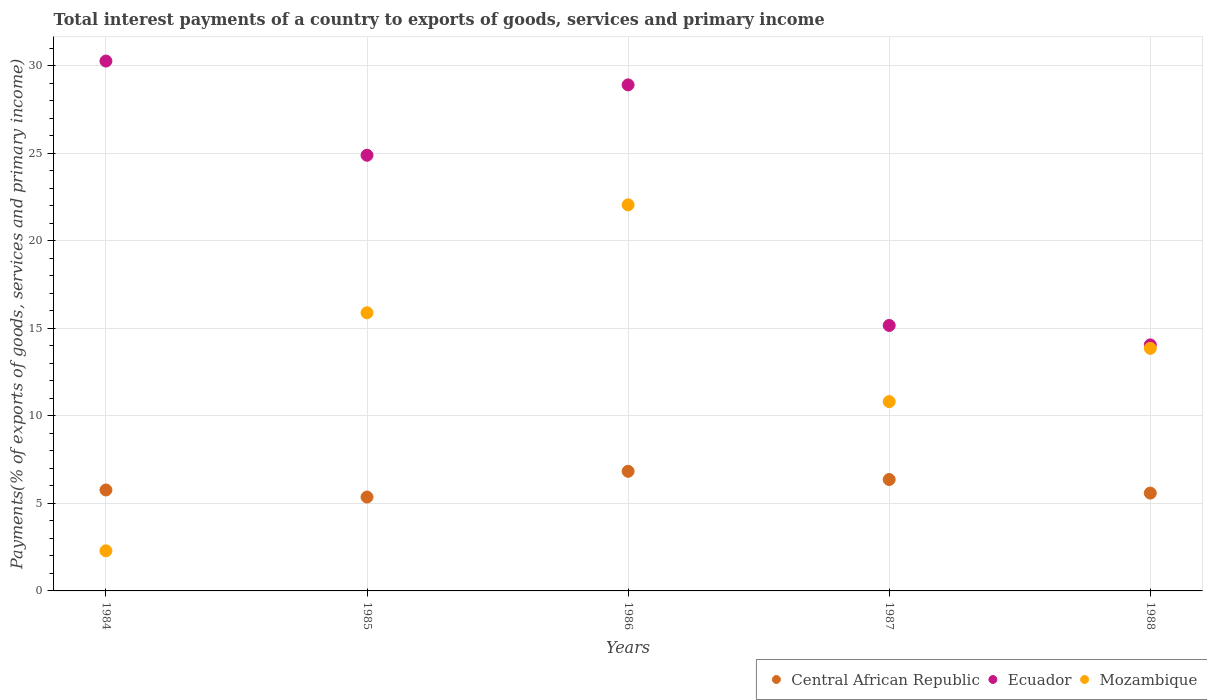How many different coloured dotlines are there?
Provide a short and direct response. 3. Is the number of dotlines equal to the number of legend labels?
Give a very brief answer. Yes. What is the total interest payments in Mozambique in 1986?
Keep it short and to the point. 22.06. Across all years, what is the maximum total interest payments in Ecuador?
Make the answer very short. 30.27. Across all years, what is the minimum total interest payments in Ecuador?
Your response must be concise. 14.06. In which year was the total interest payments in Central African Republic maximum?
Your response must be concise. 1986. What is the total total interest payments in Ecuador in the graph?
Your answer should be compact. 113.29. What is the difference between the total interest payments in Central African Republic in 1984 and that in 1986?
Your answer should be compact. -1.07. What is the difference between the total interest payments in Mozambique in 1986 and the total interest payments in Ecuador in 1987?
Provide a short and direct response. 6.89. What is the average total interest payments in Mozambique per year?
Give a very brief answer. 12.98. In the year 1988, what is the difference between the total interest payments in Mozambique and total interest payments in Ecuador?
Make the answer very short. -0.2. In how many years, is the total interest payments in Ecuador greater than 2 %?
Provide a succinct answer. 5. What is the ratio of the total interest payments in Mozambique in 1984 to that in 1986?
Keep it short and to the point. 0.1. Is the total interest payments in Mozambique in 1986 less than that in 1987?
Provide a succinct answer. No. Is the difference between the total interest payments in Mozambique in 1987 and 1988 greater than the difference between the total interest payments in Ecuador in 1987 and 1988?
Offer a very short reply. No. What is the difference between the highest and the second highest total interest payments in Central African Republic?
Your answer should be compact. 0.47. What is the difference between the highest and the lowest total interest payments in Mozambique?
Provide a succinct answer. 19.77. In how many years, is the total interest payments in Mozambique greater than the average total interest payments in Mozambique taken over all years?
Provide a short and direct response. 3. Is the total interest payments in Ecuador strictly less than the total interest payments in Mozambique over the years?
Provide a succinct answer. No. How many dotlines are there?
Provide a succinct answer. 3. Does the graph contain grids?
Give a very brief answer. Yes. Where does the legend appear in the graph?
Offer a very short reply. Bottom right. What is the title of the graph?
Offer a very short reply. Total interest payments of a country to exports of goods, services and primary income. What is the label or title of the X-axis?
Offer a very short reply. Years. What is the label or title of the Y-axis?
Your answer should be very brief. Payments(% of exports of goods, services and primary income). What is the Payments(% of exports of goods, services and primary income) of Central African Republic in 1984?
Your response must be concise. 5.77. What is the Payments(% of exports of goods, services and primary income) of Ecuador in 1984?
Offer a very short reply. 30.27. What is the Payments(% of exports of goods, services and primary income) in Mozambique in 1984?
Keep it short and to the point. 2.29. What is the Payments(% of exports of goods, services and primary income) of Central African Republic in 1985?
Keep it short and to the point. 5.36. What is the Payments(% of exports of goods, services and primary income) in Ecuador in 1985?
Offer a very short reply. 24.89. What is the Payments(% of exports of goods, services and primary income) in Mozambique in 1985?
Ensure brevity in your answer.  15.89. What is the Payments(% of exports of goods, services and primary income) in Central African Republic in 1986?
Your answer should be compact. 6.83. What is the Payments(% of exports of goods, services and primary income) in Ecuador in 1986?
Offer a terse response. 28.91. What is the Payments(% of exports of goods, services and primary income) of Mozambique in 1986?
Keep it short and to the point. 22.06. What is the Payments(% of exports of goods, services and primary income) of Central African Republic in 1987?
Offer a terse response. 6.36. What is the Payments(% of exports of goods, services and primary income) of Ecuador in 1987?
Keep it short and to the point. 15.17. What is the Payments(% of exports of goods, services and primary income) in Mozambique in 1987?
Make the answer very short. 10.82. What is the Payments(% of exports of goods, services and primary income) of Central African Republic in 1988?
Provide a succinct answer. 5.59. What is the Payments(% of exports of goods, services and primary income) in Ecuador in 1988?
Offer a terse response. 14.06. What is the Payments(% of exports of goods, services and primary income) in Mozambique in 1988?
Make the answer very short. 13.86. Across all years, what is the maximum Payments(% of exports of goods, services and primary income) of Central African Republic?
Your answer should be compact. 6.83. Across all years, what is the maximum Payments(% of exports of goods, services and primary income) in Ecuador?
Provide a short and direct response. 30.27. Across all years, what is the maximum Payments(% of exports of goods, services and primary income) of Mozambique?
Your answer should be compact. 22.06. Across all years, what is the minimum Payments(% of exports of goods, services and primary income) in Central African Republic?
Your response must be concise. 5.36. Across all years, what is the minimum Payments(% of exports of goods, services and primary income) in Ecuador?
Offer a very short reply. 14.06. Across all years, what is the minimum Payments(% of exports of goods, services and primary income) of Mozambique?
Offer a terse response. 2.29. What is the total Payments(% of exports of goods, services and primary income) of Central African Republic in the graph?
Provide a succinct answer. 29.92. What is the total Payments(% of exports of goods, services and primary income) of Ecuador in the graph?
Offer a very short reply. 113.29. What is the total Payments(% of exports of goods, services and primary income) in Mozambique in the graph?
Give a very brief answer. 64.91. What is the difference between the Payments(% of exports of goods, services and primary income) in Central African Republic in 1984 and that in 1985?
Ensure brevity in your answer.  0.4. What is the difference between the Payments(% of exports of goods, services and primary income) in Ecuador in 1984 and that in 1985?
Offer a terse response. 5.38. What is the difference between the Payments(% of exports of goods, services and primary income) in Mozambique in 1984 and that in 1985?
Provide a succinct answer. -13.6. What is the difference between the Payments(% of exports of goods, services and primary income) in Central African Republic in 1984 and that in 1986?
Ensure brevity in your answer.  -1.07. What is the difference between the Payments(% of exports of goods, services and primary income) of Ecuador in 1984 and that in 1986?
Your answer should be very brief. 1.36. What is the difference between the Payments(% of exports of goods, services and primary income) of Mozambique in 1984 and that in 1986?
Provide a short and direct response. -19.77. What is the difference between the Payments(% of exports of goods, services and primary income) of Central African Republic in 1984 and that in 1987?
Offer a terse response. -0.6. What is the difference between the Payments(% of exports of goods, services and primary income) in Ecuador in 1984 and that in 1987?
Offer a terse response. 15.1. What is the difference between the Payments(% of exports of goods, services and primary income) of Mozambique in 1984 and that in 1987?
Make the answer very short. -8.52. What is the difference between the Payments(% of exports of goods, services and primary income) of Central African Republic in 1984 and that in 1988?
Offer a terse response. 0.18. What is the difference between the Payments(% of exports of goods, services and primary income) in Ecuador in 1984 and that in 1988?
Provide a succinct answer. 16.21. What is the difference between the Payments(% of exports of goods, services and primary income) in Mozambique in 1984 and that in 1988?
Keep it short and to the point. -11.57. What is the difference between the Payments(% of exports of goods, services and primary income) of Central African Republic in 1985 and that in 1986?
Ensure brevity in your answer.  -1.47. What is the difference between the Payments(% of exports of goods, services and primary income) in Ecuador in 1985 and that in 1986?
Your response must be concise. -4.02. What is the difference between the Payments(% of exports of goods, services and primary income) in Mozambique in 1985 and that in 1986?
Make the answer very short. -6.17. What is the difference between the Payments(% of exports of goods, services and primary income) in Central African Republic in 1985 and that in 1987?
Keep it short and to the point. -1. What is the difference between the Payments(% of exports of goods, services and primary income) in Ecuador in 1985 and that in 1987?
Keep it short and to the point. 9.72. What is the difference between the Payments(% of exports of goods, services and primary income) in Mozambique in 1985 and that in 1987?
Offer a terse response. 5.08. What is the difference between the Payments(% of exports of goods, services and primary income) of Central African Republic in 1985 and that in 1988?
Keep it short and to the point. -0.23. What is the difference between the Payments(% of exports of goods, services and primary income) in Ecuador in 1985 and that in 1988?
Ensure brevity in your answer.  10.83. What is the difference between the Payments(% of exports of goods, services and primary income) in Mozambique in 1985 and that in 1988?
Keep it short and to the point. 2.03. What is the difference between the Payments(% of exports of goods, services and primary income) of Central African Republic in 1986 and that in 1987?
Make the answer very short. 0.47. What is the difference between the Payments(% of exports of goods, services and primary income) of Ecuador in 1986 and that in 1987?
Ensure brevity in your answer.  13.74. What is the difference between the Payments(% of exports of goods, services and primary income) of Mozambique in 1986 and that in 1987?
Your answer should be very brief. 11.24. What is the difference between the Payments(% of exports of goods, services and primary income) in Central African Republic in 1986 and that in 1988?
Provide a short and direct response. 1.24. What is the difference between the Payments(% of exports of goods, services and primary income) of Ecuador in 1986 and that in 1988?
Give a very brief answer. 14.85. What is the difference between the Payments(% of exports of goods, services and primary income) in Mozambique in 1986 and that in 1988?
Your answer should be compact. 8.2. What is the difference between the Payments(% of exports of goods, services and primary income) in Central African Republic in 1987 and that in 1988?
Make the answer very short. 0.77. What is the difference between the Payments(% of exports of goods, services and primary income) of Ecuador in 1987 and that in 1988?
Your response must be concise. 1.11. What is the difference between the Payments(% of exports of goods, services and primary income) of Mozambique in 1987 and that in 1988?
Make the answer very short. -3.04. What is the difference between the Payments(% of exports of goods, services and primary income) in Central African Republic in 1984 and the Payments(% of exports of goods, services and primary income) in Ecuador in 1985?
Ensure brevity in your answer.  -19.12. What is the difference between the Payments(% of exports of goods, services and primary income) of Central African Republic in 1984 and the Payments(% of exports of goods, services and primary income) of Mozambique in 1985?
Your response must be concise. -10.12. What is the difference between the Payments(% of exports of goods, services and primary income) in Ecuador in 1984 and the Payments(% of exports of goods, services and primary income) in Mozambique in 1985?
Keep it short and to the point. 14.38. What is the difference between the Payments(% of exports of goods, services and primary income) of Central African Republic in 1984 and the Payments(% of exports of goods, services and primary income) of Ecuador in 1986?
Provide a succinct answer. -23.14. What is the difference between the Payments(% of exports of goods, services and primary income) of Central African Republic in 1984 and the Payments(% of exports of goods, services and primary income) of Mozambique in 1986?
Give a very brief answer. -16.29. What is the difference between the Payments(% of exports of goods, services and primary income) of Ecuador in 1984 and the Payments(% of exports of goods, services and primary income) of Mozambique in 1986?
Keep it short and to the point. 8.21. What is the difference between the Payments(% of exports of goods, services and primary income) in Central African Republic in 1984 and the Payments(% of exports of goods, services and primary income) in Ecuador in 1987?
Give a very brief answer. -9.4. What is the difference between the Payments(% of exports of goods, services and primary income) of Central African Republic in 1984 and the Payments(% of exports of goods, services and primary income) of Mozambique in 1987?
Provide a short and direct response. -5.05. What is the difference between the Payments(% of exports of goods, services and primary income) of Ecuador in 1984 and the Payments(% of exports of goods, services and primary income) of Mozambique in 1987?
Provide a short and direct response. 19.46. What is the difference between the Payments(% of exports of goods, services and primary income) in Central African Republic in 1984 and the Payments(% of exports of goods, services and primary income) in Ecuador in 1988?
Your answer should be compact. -8.29. What is the difference between the Payments(% of exports of goods, services and primary income) in Central African Republic in 1984 and the Payments(% of exports of goods, services and primary income) in Mozambique in 1988?
Your answer should be very brief. -8.09. What is the difference between the Payments(% of exports of goods, services and primary income) in Ecuador in 1984 and the Payments(% of exports of goods, services and primary income) in Mozambique in 1988?
Give a very brief answer. 16.41. What is the difference between the Payments(% of exports of goods, services and primary income) of Central African Republic in 1985 and the Payments(% of exports of goods, services and primary income) of Ecuador in 1986?
Provide a short and direct response. -23.55. What is the difference between the Payments(% of exports of goods, services and primary income) of Central African Republic in 1985 and the Payments(% of exports of goods, services and primary income) of Mozambique in 1986?
Provide a short and direct response. -16.69. What is the difference between the Payments(% of exports of goods, services and primary income) of Ecuador in 1985 and the Payments(% of exports of goods, services and primary income) of Mozambique in 1986?
Your answer should be compact. 2.83. What is the difference between the Payments(% of exports of goods, services and primary income) in Central African Republic in 1985 and the Payments(% of exports of goods, services and primary income) in Ecuador in 1987?
Your answer should be very brief. -9.8. What is the difference between the Payments(% of exports of goods, services and primary income) in Central African Republic in 1985 and the Payments(% of exports of goods, services and primary income) in Mozambique in 1987?
Make the answer very short. -5.45. What is the difference between the Payments(% of exports of goods, services and primary income) of Ecuador in 1985 and the Payments(% of exports of goods, services and primary income) of Mozambique in 1987?
Ensure brevity in your answer.  14.07. What is the difference between the Payments(% of exports of goods, services and primary income) of Central African Republic in 1985 and the Payments(% of exports of goods, services and primary income) of Ecuador in 1988?
Your response must be concise. -8.69. What is the difference between the Payments(% of exports of goods, services and primary income) in Central African Republic in 1985 and the Payments(% of exports of goods, services and primary income) in Mozambique in 1988?
Your response must be concise. -8.5. What is the difference between the Payments(% of exports of goods, services and primary income) in Ecuador in 1985 and the Payments(% of exports of goods, services and primary income) in Mozambique in 1988?
Your answer should be compact. 11.03. What is the difference between the Payments(% of exports of goods, services and primary income) of Central African Republic in 1986 and the Payments(% of exports of goods, services and primary income) of Ecuador in 1987?
Provide a succinct answer. -8.33. What is the difference between the Payments(% of exports of goods, services and primary income) of Central African Republic in 1986 and the Payments(% of exports of goods, services and primary income) of Mozambique in 1987?
Offer a terse response. -3.98. What is the difference between the Payments(% of exports of goods, services and primary income) of Ecuador in 1986 and the Payments(% of exports of goods, services and primary income) of Mozambique in 1987?
Give a very brief answer. 18.09. What is the difference between the Payments(% of exports of goods, services and primary income) of Central African Republic in 1986 and the Payments(% of exports of goods, services and primary income) of Ecuador in 1988?
Your answer should be compact. -7.22. What is the difference between the Payments(% of exports of goods, services and primary income) in Central African Republic in 1986 and the Payments(% of exports of goods, services and primary income) in Mozambique in 1988?
Your answer should be very brief. -7.02. What is the difference between the Payments(% of exports of goods, services and primary income) in Ecuador in 1986 and the Payments(% of exports of goods, services and primary income) in Mozambique in 1988?
Give a very brief answer. 15.05. What is the difference between the Payments(% of exports of goods, services and primary income) in Central African Republic in 1987 and the Payments(% of exports of goods, services and primary income) in Ecuador in 1988?
Give a very brief answer. -7.69. What is the difference between the Payments(% of exports of goods, services and primary income) in Central African Republic in 1987 and the Payments(% of exports of goods, services and primary income) in Mozambique in 1988?
Offer a very short reply. -7.49. What is the difference between the Payments(% of exports of goods, services and primary income) of Ecuador in 1987 and the Payments(% of exports of goods, services and primary income) of Mozambique in 1988?
Your answer should be very brief. 1.31. What is the average Payments(% of exports of goods, services and primary income) in Central African Republic per year?
Keep it short and to the point. 5.98. What is the average Payments(% of exports of goods, services and primary income) in Ecuador per year?
Your answer should be very brief. 22.66. What is the average Payments(% of exports of goods, services and primary income) of Mozambique per year?
Provide a succinct answer. 12.98. In the year 1984, what is the difference between the Payments(% of exports of goods, services and primary income) of Central African Republic and Payments(% of exports of goods, services and primary income) of Ecuador?
Ensure brevity in your answer.  -24.5. In the year 1984, what is the difference between the Payments(% of exports of goods, services and primary income) in Central African Republic and Payments(% of exports of goods, services and primary income) in Mozambique?
Make the answer very short. 3.48. In the year 1984, what is the difference between the Payments(% of exports of goods, services and primary income) in Ecuador and Payments(% of exports of goods, services and primary income) in Mozambique?
Give a very brief answer. 27.98. In the year 1985, what is the difference between the Payments(% of exports of goods, services and primary income) of Central African Republic and Payments(% of exports of goods, services and primary income) of Ecuador?
Offer a very short reply. -19.53. In the year 1985, what is the difference between the Payments(% of exports of goods, services and primary income) of Central African Republic and Payments(% of exports of goods, services and primary income) of Mozambique?
Your answer should be compact. -10.53. In the year 1985, what is the difference between the Payments(% of exports of goods, services and primary income) in Ecuador and Payments(% of exports of goods, services and primary income) in Mozambique?
Your answer should be compact. 9. In the year 1986, what is the difference between the Payments(% of exports of goods, services and primary income) in Central African Republic and Payments(% of exports of goods, services and primary income) in Ecuador?
Your answer should be compact. -22.08. In the year 1986, what is the difference between the Payments(% of exports of goods, services and primary income) in Central African Republic and Payments(% of exports of goods, services and primary income) in Mozambique?
Offer a terse response. -15.22. In the year 1986, what is the difference between the Payments(% of exports of goods, services and primary income) of Ecuador and Payments(% of exports of goods, services and primary income) of Mozambique?
Your response must be concise. 6.85. In the year 1987, what is the difference between the Payments(% of exports of goods, services and primary income) in Central African Republic and Payments(% of exports of goods, services and primary income) in Ecuador?
Offer a terse response. -8.8. In the year 1987, what is the difference between the Payments(% of exports of goods, services and primary income) of Central African Republic and Payments(% of exports of goods, services and primary income) of Mozambique?
Give a very brief answer. -4.45. In the year 1987, what is the difference between the Payments(% of exports of goods, services and primary income) of Ecuador and Payments(% of exports of goods, services and primary income) of Mozambique?
Provide a short and direct response. 4.35. In the year 1988, what is the difference between the Payments(% of exports of goods, services and primary income) of Central African Republic and Payments(% of exports of goods, services and primary income) of Ecuador?
Provide a short and direct response. -8.47. In the year 1988, what is the difference between the Payments(% of exports of goods, services and primary income) in Central African Republic and Payments(% of exports of goods, services and primary income) in Mozambique?
Your response must be concise. -8.27. In the year 1988, what is the difference between the Payments(% of exports of goods, services and primary income) in Ecuador and Payments(% of exports of goods, services and primary income) in Mozambique?
Provide a succinct answer. 0.2. What is the ratio of the Payments(% of exports of goods, services and primary income) in Central African Republic in 1984 to that in 1985?
Give a very brief answer. 1.08. What is the ratio of the Payments(% of exports of goods, services and primary income) of Ecuador in 1984 to that in 1985?
Give a very brief answer. 1.22. What is the ratio of the Payments(% of exports of goods, services and primary income) in Mozambique in 1984 to that in 1985?
Give a very brief answer. 0.14. What is the ratio of the Payments(% of exports of goods, services and primary income) of Central African Republic in 1984 to that in 1986?
Provide a short and direct response. 0.84. What is the ratio of the Payments(% of exports of goods, services and primary income) in Ecuador in 1984 to that in 1986?
Provide a short and direct response. 1.05. What is the ratio of the Payments(% of exports of goods, services and primary income) in Mozambique in 1984 to that in 1986?
Provide a succinct answer. 0.1. What is the ratio of the Payments(% of exports of goods, services and primary income) in Central African Republic in 1984 to that in 1987?
Make the answer very short. 0.91. What is the ratio of the Payments(% of exports of goods, services and primary income) of Ecuador in 1984 to that in 1987?
Your answer should be very brief. 2. What is the ratio of the Payments(% of exports of goods, services and primary income) in Mozambique in 1984 to that in 1987?
Offer a very short reply. 0.21. What is the ratio of the Payments(% of exports of goods, services and primary income) in Central African Republic in 1984 to that in 1988?
Provide a succinct answer. 1.03. What is the ratio of the Payments(% of exports of goods, services and primary income) of Ecuador in 1984 to that in 1988?
Your answer should be very brief. 2.15. What is the ratio of the Payments(% of exports of goods, services and primary income) in Mozambique in 1984 to that in 1988?
Give a very brief answer. 0.17. What is the ratio of the Payments(% of exports of goods, services and primary income) of Central African Republic in 1985 to that in 1986?
Offer a terse response. 0.78. What is the ratio of the Payments(% of exports of goods, services and primary income) of Ecuador in 1985 to that in 1986?
Your response must be concise. 0.86. What is the ratio of the Payments(% of exports of goods, services and primary income) in Mozambique in 1985 to that in 1986?
Provide a short and direct response. 0.72. What is the ratio of the Payments(% of exports of goods, services and primary income) of Central African Republic in 1985 to that in 1987?
Make the answer very short. 0.84. What is the ratio of the Payments(% of exports of goods, services and primary income) in Ecuador in 1985 to that in 1987?
Ensure brevity in your answer.  1.64. What is the ratio of the Payments(% of exports of goods, services and primary income) in Mozambique in 1985 to that in 1987?
Offer a very short reply. 1.47. What is the ratio of the Payments(% of exports of goods, services and primary income) of Central African Republic in 1985 to that in 1988?
Offer a very short reply. 0.96. What is the ratio of the Payments(% of exports of goods, services and primary income) of Ecuador in 1985 to that in 1988?
Your answer should be very brief. 1.77. What is the ratio of the Payments(% of exports of goods, services and primary income) in Mozambique in 1985 to that in 1988?
Your response must be concise. 1.15. What is the ratio of the Payments(% of exports of goods, services and primary income) in Central African Republic in 1986 to that in 1987?
Provide a succinct answer. 1.07. What is the ratio of the Payments(% of exports of goods, services and primary income) of Ecuador in 1986 to that in 1987?
Offer a very short reply. 1.91. What is the ratio of the Payments(% of exports of goods, services and primary income) in Mozambique in 1986 to that in 1987?
Make the answer very short. 2.04. What is the ratio of the Payments(% of exports of goods, services and primary income) of Central African Republic in 1986 to that in 1988?
Give a very brief answer. 1.22. What is the ratio of the Payments(% of exports of goods, services and primary income) of Ecuador in 1986 to that in 1988?
Give a very brief answer. 2.06. What is the ratio of the Payments(% of exports of goods, services and primary income) of Mozambique in 1986 to that in 1988?
Make the answer very short. 1.59. What is the ratio of the Payments(% of exports of goods, services and primary income) in Central African Republic in 1987 to that in 1988?
Ensure brevity in your answer.  1.14. What is the ratio of the Payments(% of exports of goods, services and primary income) in Ecuador in 1987 to that in 1988?
Provide a succinct answer. 1.08. What is the ratio of the Payments(% of exports of goods, services and primary income) in Mozambique in 1987 to that in 1988?
Offer a very short reply. 0.78. What is the difference between the highest and the second highest Payments(% of exports of goods, services and primary income) of Central African Republic?
Your response must be concise. 0.47. What is the difference between the highest and the second highest Payments(% of exports of goods, services and primary income) of Ecuador?
Your response must be concise. 1.36. What is the difference between the highest and the second highest Payments(% of exports of goods, services and primary income) of Mozambique?
Your response must be concise. 6.17. What is the difference between the highest and the lowest Payments(% of exports of goods, services and primary income) in Central African Republic?
Make the answer very short. 1.47. What is the difference between the highest and the lowest Payments(% of exports of goods, services and primary income) of Ecuador?
Offer a very short reply. 16.21. What is the difference between the highest and the lowest Payments(% of exports of goods, services and primary income) in Mozambique?
Offer a very short reply. 19.77. 